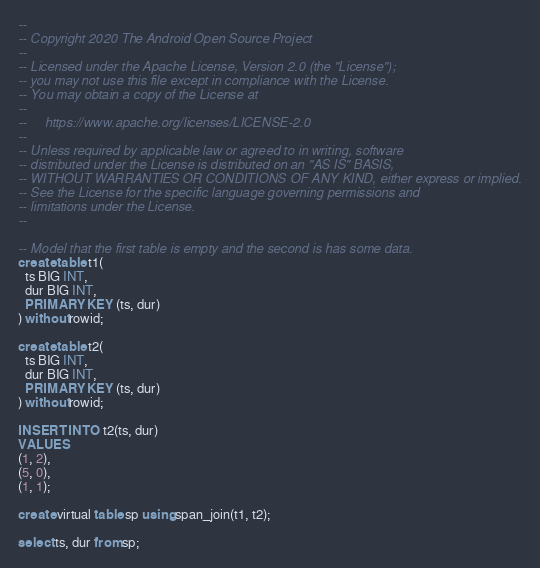<code> <loc_0><loc_0><loc_500><loc_500><_SQL_>--
-- Copyright 2020 The Android Open Source Project
--
-- Licensed under the Apache License, Version 2.0 (the "License");
-- you may not use this file except in compliance with the License.
-- You may obtain a copy of the License at
--
--     https://www.apache.org/licenses/LICENSE-2.0
--
-- Unless required by applicable law or agreed to in writing, software
-- distributed under the License is distributed on an "AS IS" BASIS,
-- WITHOUT WARRANTIES OR CONDITIONS OF ANY KIND, either express or implied.
-- See the License for the specific language governing permissions and
-- limitations under the License.
--

-- Model that the first table is empty and the second is has some data.
create table t1(
  ts BIG INT,
  dur BIG INT,
  PRIMARY KEY (ts, dur)
) without rowid;

create table t2(
  ts BIG INT,
  dur BIG INT,
  PRIMARY KEY (ts, dur)
) without rowid;

INSERT INTO t2(ts, dur)
VALUES
(1, 2),
(5, 0),
(1, 1);

create virtual table sp using span_join(t1, t2);

select ts, dur from sp;
</code> 